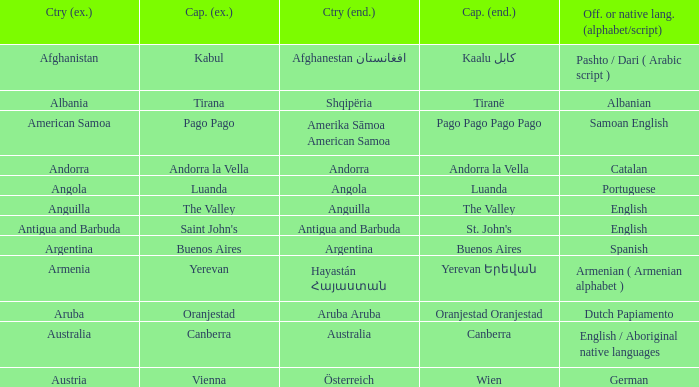What is the English name given to the city of St. John's? Saint John's. 